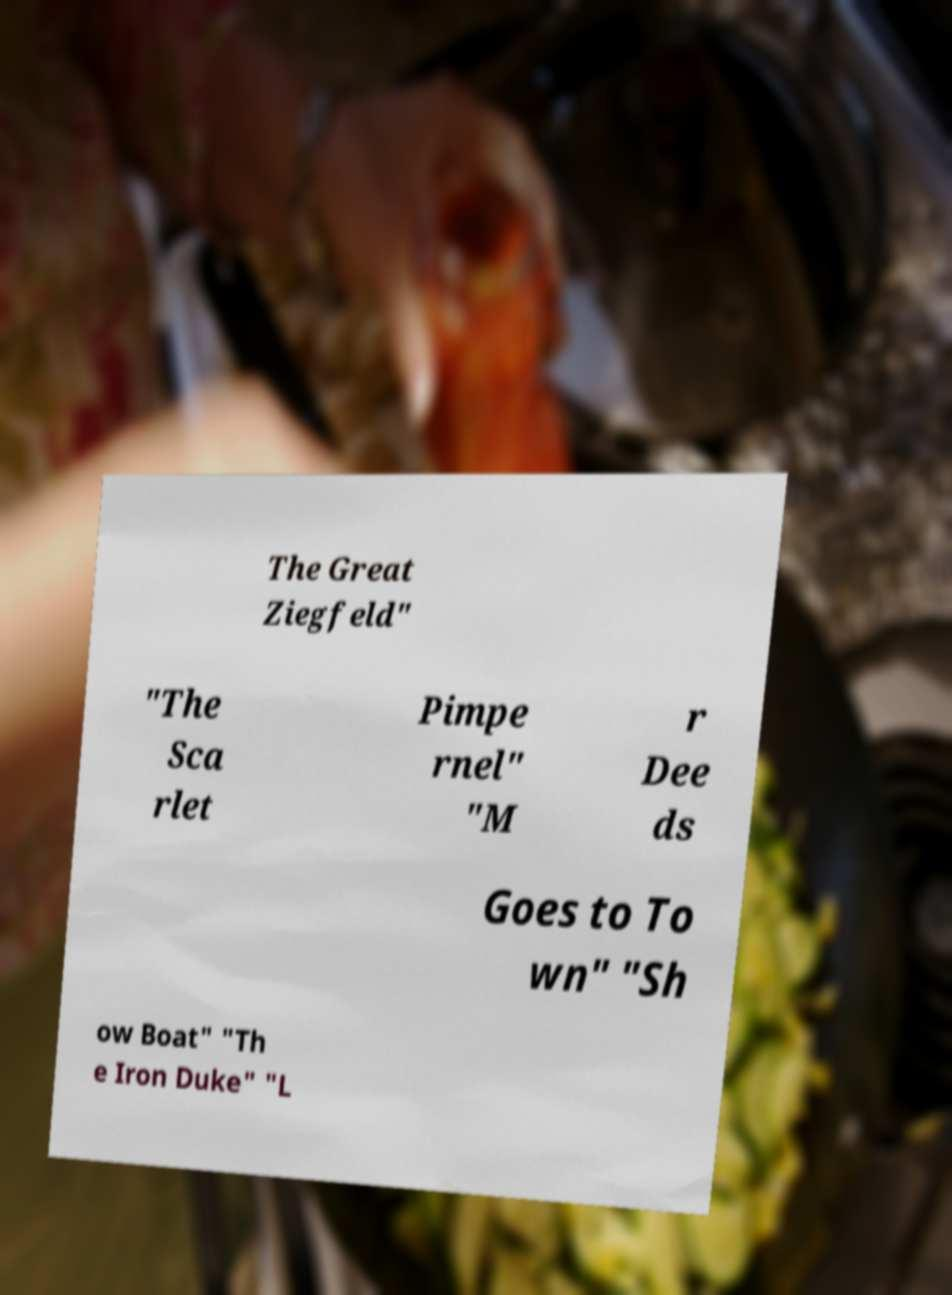Can you read and provide the text displayed in the image?This photo seems to have some interesting text. Can you extract and type it out for me? The Great Ziegfeld" "The Sca rlet Pimpe rnel" "M r Dee ds Goes to To wn" "Sh ow Boat" "Th e Iron Duke" "L 